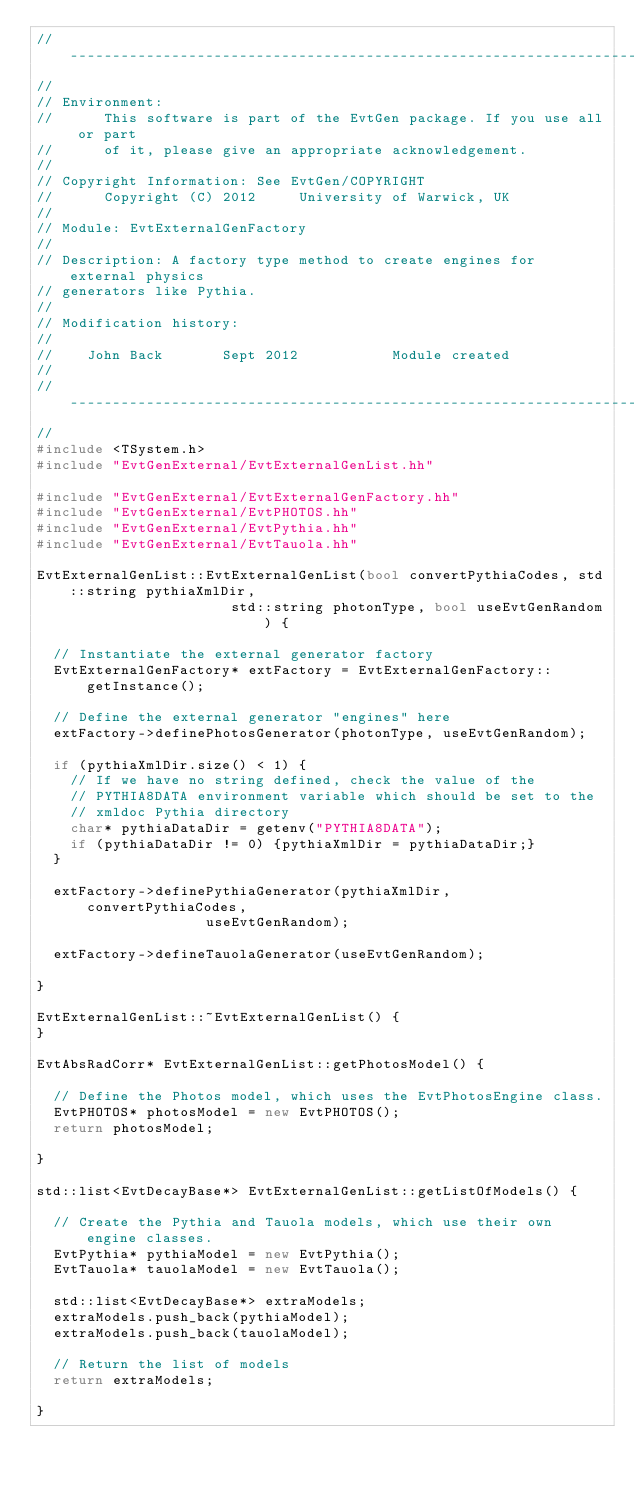Convert code to text. <code><loc_0><loc_0><loc_500><loc_500><_C++_>//--------------------------------------------------------------------------
//
// Environment:
//      This software is part of the EvtGen package. If you use all or part
//      of it, please give an appropriate acknowledgement.
//
// Copyright Information: See EvtGen/COPYRIGHT
//      Copyright (C) 2012     University of Warwick, UK
//
// Module: EvtExternalGenFactory
//
// Description: A factory type method to create engines for external physics
// generators like Pythia.
//
// Modification history:
//
//    John Back       Sept 2012           Module created
//
//------------------------------------------------------------------------------
//
#include <TSystem.h>
#include "EvtGenExternal/EvtExternalGenList.hh"

#include "EvtGenExternal/EvtExternalGenFactory.hh"
#include "EvtGenExternal/EvtPHOTOS.hh"
#include "EvtGenExternal/EvtPythia.hh"
#include "EvtGenExternal/EvtTauola.hh"

EvtExternalGenList::EvtExternalGenList(bool convertPythiaCodes, std::string pythiaXmlDir,
				       std::string photonType, bool useEvtGenRandom) {

  // Instantiate the external generator factory
  EvtExternalGenFactory* extFactory = EvtExternalGenFactory::getInstance();

  // Define the external generator "engines" here
  extFactory->definePhotosGenerator(photonType, useEvtGenRandom);

  if (pythiaXmlDir.size() < 1) {
    // If we have no string defined, check the value of the
    // PYTHIA8DATA environment variable which should be set to the 
    // xmldoc Pythia directory
    char* pythiaDataDir = getenv("PYTHIA8DATA");
    if (pythiaDataDir != 0) {pythiaXmlDir = pythiaDataDir;}
  }

  extFactory->definePythiaGenerator(pythiaXmlDir, convertPythiaCodes,
				    useEvtGenRandom);

  extFactory->defineTauolaGenerator(useEvtGenRandom);  

}

EvtExternalGenList::~EvtExternalGenList() {
}

EvtAbsRadCorr* EvtExternalGenList::getPhotosModel() {

  // Define the Photos model, which uses the EvtPhotosEngine class.
  EvtPHOTOS* photosModel = new EvtPHOTOS();
  return photosModel;

}

std::list<EvtDecayBase*> EvtExternalGenList::getListOfModels() {

  // Create the Pythia and Tauola models, which use their own engine classes.
  EvtPythia* pythiaModel = new EvtPythia();
  EvtTauola* tauolaModel = new EvtTauola();

  std::list<EvtDecayBase*> extraModels;
  extraModels.push_back(pythiaModel);
  extraModels.push_back(tauolaModel);

  // Return the list of models
  return extraModels;

}
</code> 